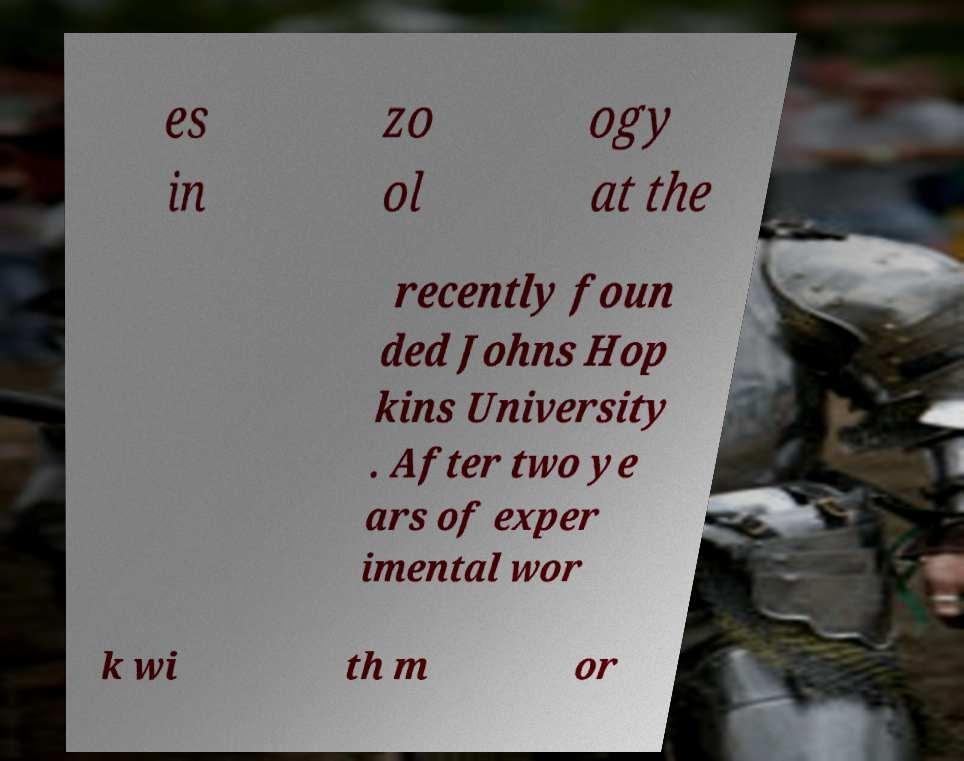Please read and relay the text visible in this image. What does it say? es in zo ol ogy at the recently foun ded Johns Hop kins University . After two ye ars of exper imental wor k wi th m or 